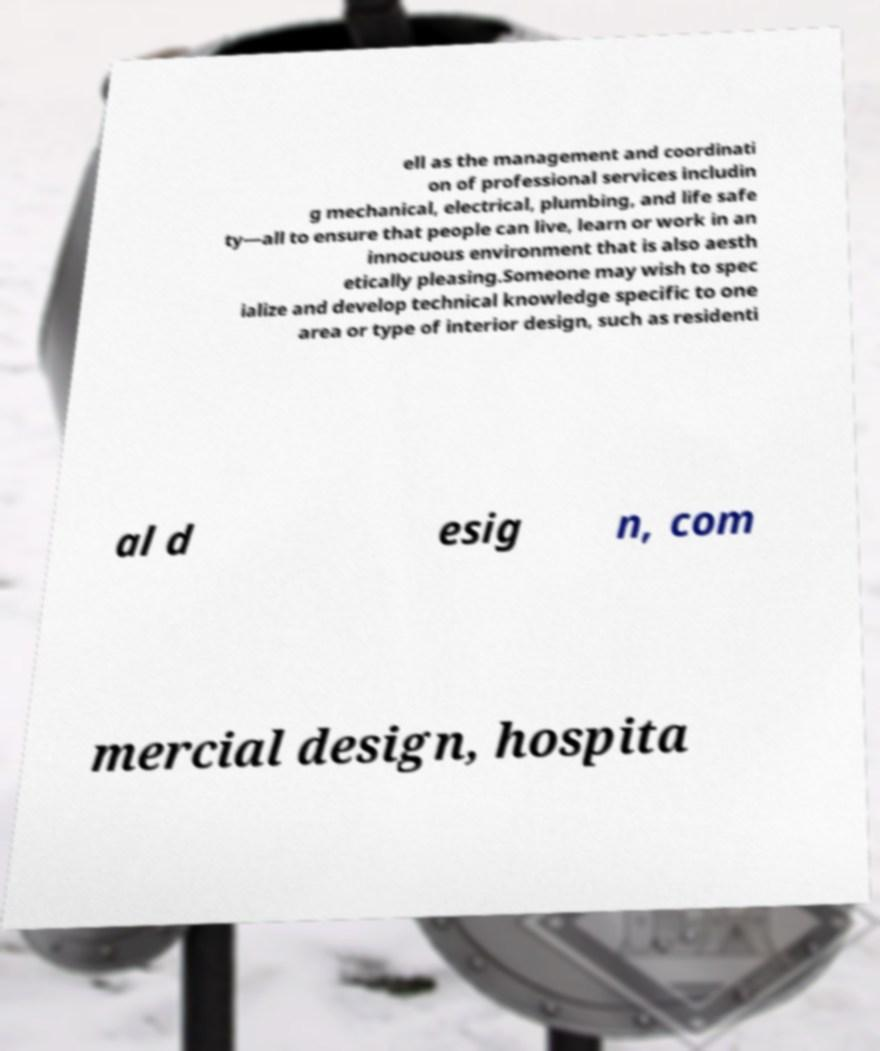There's text embedded in this image that I need extracted. Can you transcribe it verbatim? ell as the management and coordinati on of professional services includin g mechanical, electrical, plumbing, and life safe ty—all to ensure that people can live, learn or work in an innocuous environment that is also aesth etically pleasing.Someone may wish to spec ialize and develop technical knowledge specific to one area or type of interior design, such as residenti al d esig n, com mercial design, hospita 